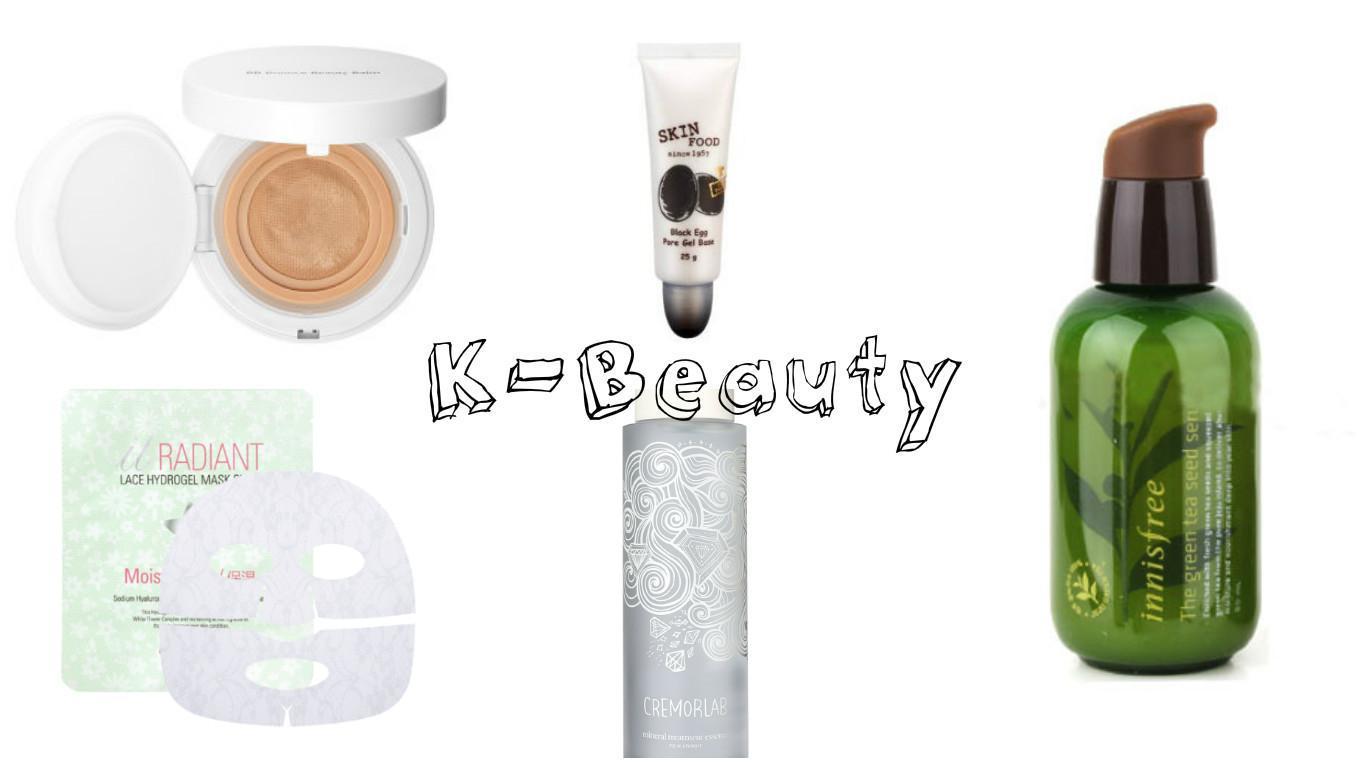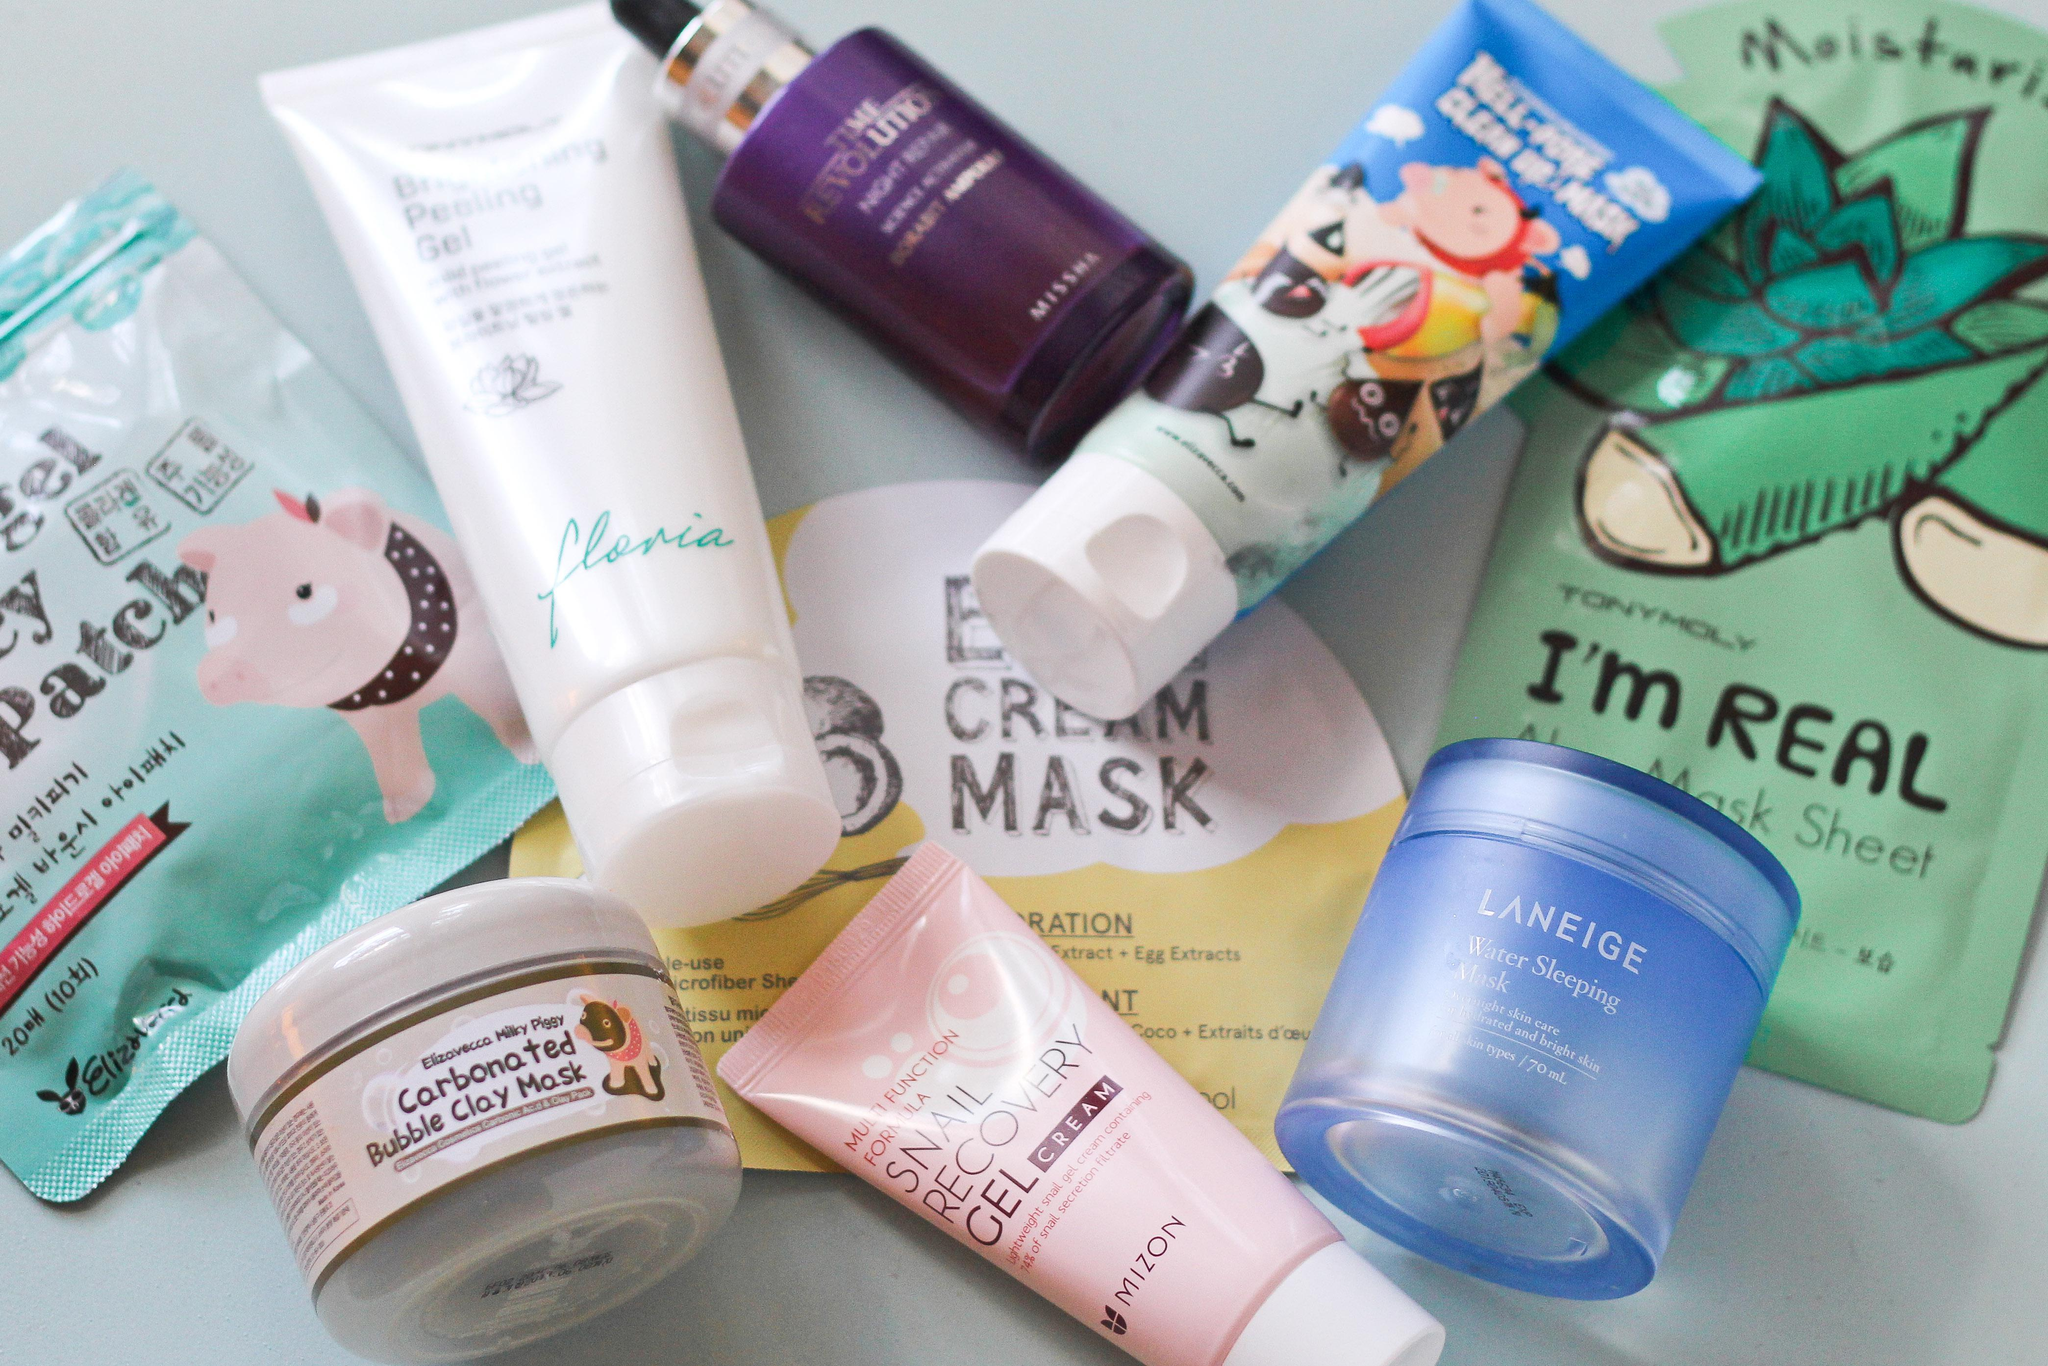The first image is the image on the left, the second image is the image on the right. Assess this claim about the two images: "One image shows no more than three items, which are laid flat on a surface, and the other image includes multiple products displayed standing upright.". Correct or not? Answer yes or no. No. The first image is the image on the left, the second image is the image on the right. Evaluate the accuracy of this statement regarding the images: "IN at least one image there is at least one lipstick lying on it's side and one chapstick in a round container.". Is it true? Answer yes or no. No. 